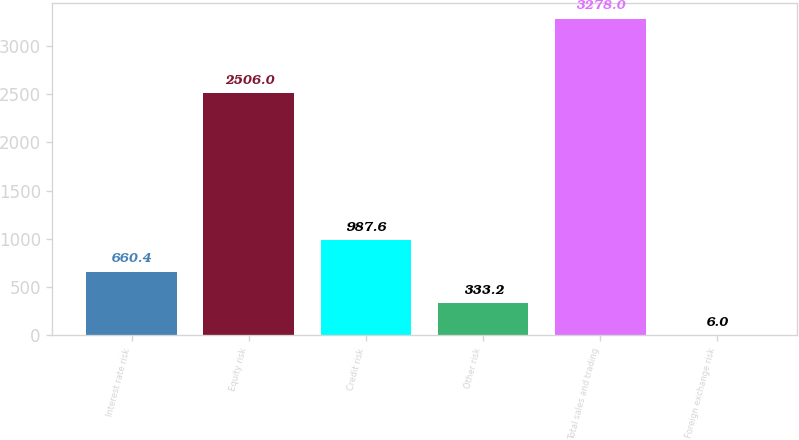Convert chart to OTSL. <chart><loc_0><loc_0><loc_500><loc_500><bar_chart><fcel>Interest rate risk<fcel>Equity risk<fcel>Credit risk<fcel>Other risk<fcel>Total sales and trading<fcel>Foreign exchange risk<nl><fcel>660.4<fcel>2506<fcel>987.6<fcel>333.2<fcel>3278<fcel>6<nl></chart> 